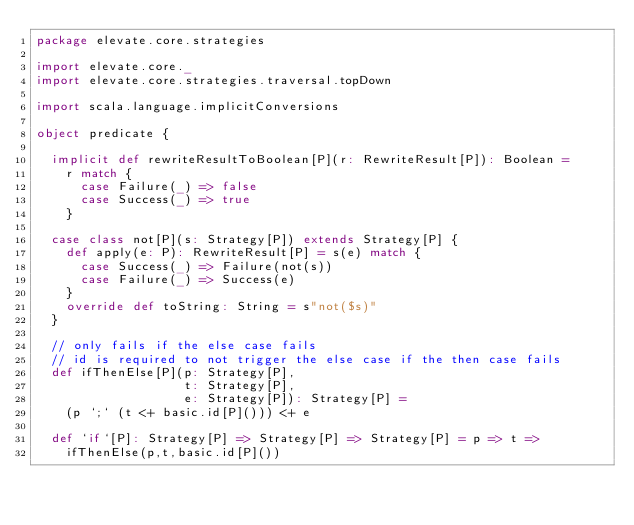Convert code to text. <code><loc_0><loc_0><loc_500><loc_500><_Scala_>package elevate.core.strategies

import elevate.core._
import elevate.core.strategies.traversal.topDown

import scala.language.implicitConversions

object predicate {

  implicit def rewriteResultToBoolean[P](r: RewriteResult[P]): Boolean =
    r match {
      case Failure(_) => false
      case Success(_) => true
    }

  case class not[P](s: Strategy[P]) extends Strategy[P] {
    def apply(e: P): RewriteResult[P] = s(e) match {
      case Success(_) => Failure(not(s))
      case Failure(_) => Success(e)
    }
    override def toString: String = s"not($s)"
  }

  // only fails if the else case fails
  // id is required to not trigger the else case if the then case fails
  def ifThenElse[P](p: Strategy[P],
                    t: Strategy[P],
                    e: Strategy[P]): Strategy[P] =
    (p `;` (t <+ basic.id[P]())) <+ e

  def `if`[P]: Strategy[P] => Strategy[P] => Strategy[P] = p => t =>
    ifThenElse(p,t,basic.id[P]())
</code> 